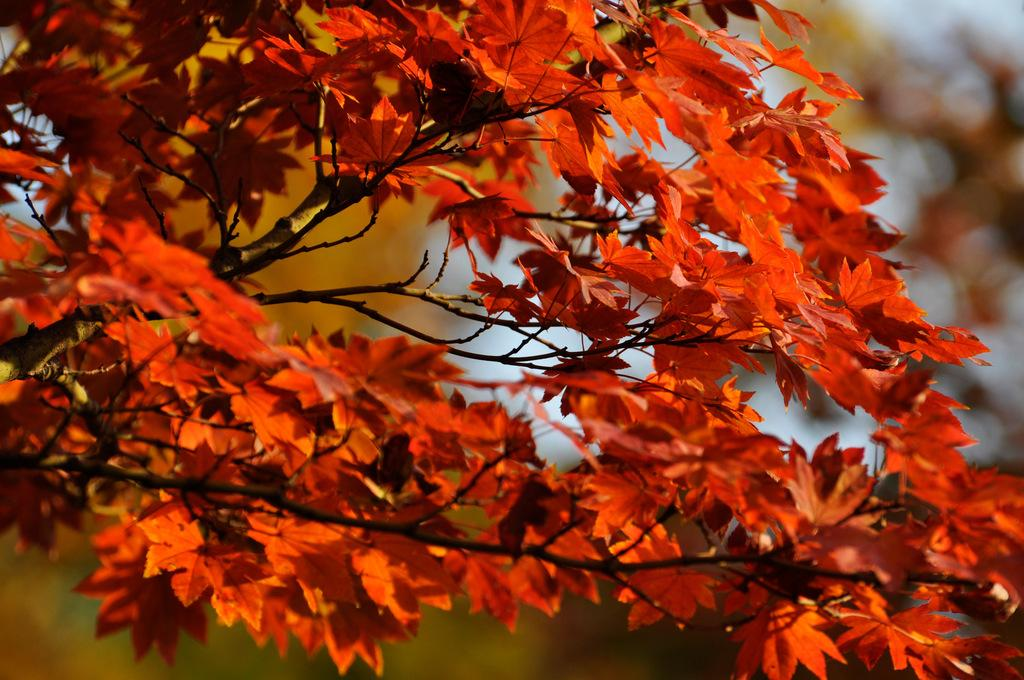What is the main subject of the image? The main subject of the image is a tree. What is unique characteristic do the leaves of the tree have? The leaves of the tree are red. Can you describe the background of the image? The background of the image is blurred. What type of flowers can be seen growing in the lunchroom in the image? There is no lunchroom or flowers present in the image; it features a tree with red leaves and a blurred background. 